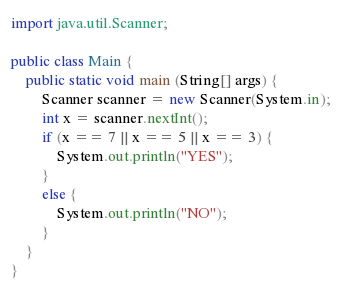<code> <loc_0><loc_0><loc_500><loc_500><_Java_>import java.util.Scanner;

public class Main {
    public static void main (String[] args) {
        Scanner scanner = new Scanner(System.in);
        int x = scanner.nextInt();
        if (x == 7 || x == 5 || x == 3) {
            System.out.println("YES");
        }
        else {
            System.out.println("NO");
        }
    }
}</code> 